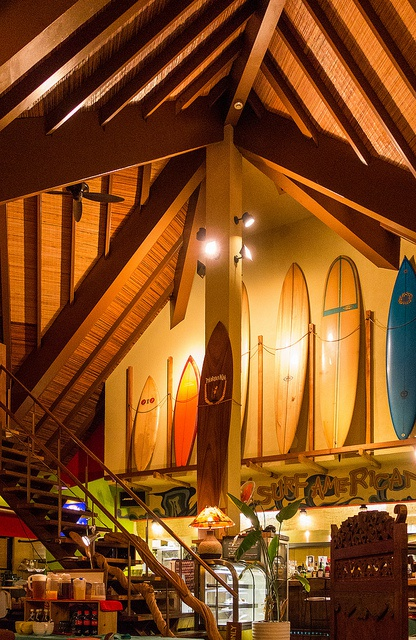Describe the objects in this image and their specific colors. I can see surfboard in black, orange, and tan tones, potted plant in black, olive, and maroon tones, surfboard in black, orange, khaki, and ivory tones, surfboard in black, maroon, and brown tones, and surfboard in black, blue, darkblue, and teal tones in this image. 